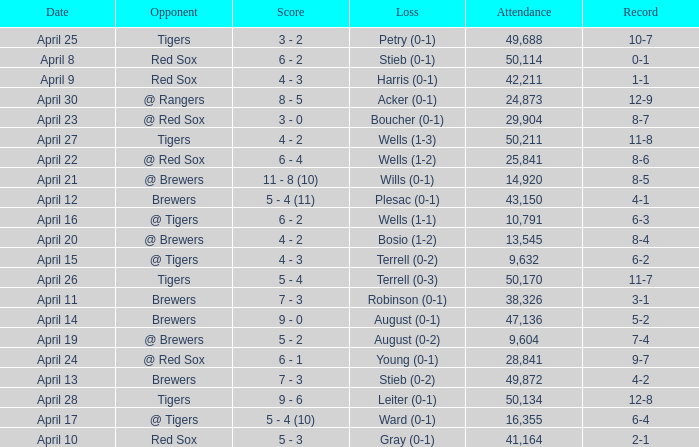Which opponent has a loss of wells (1-3)? Tigers. 